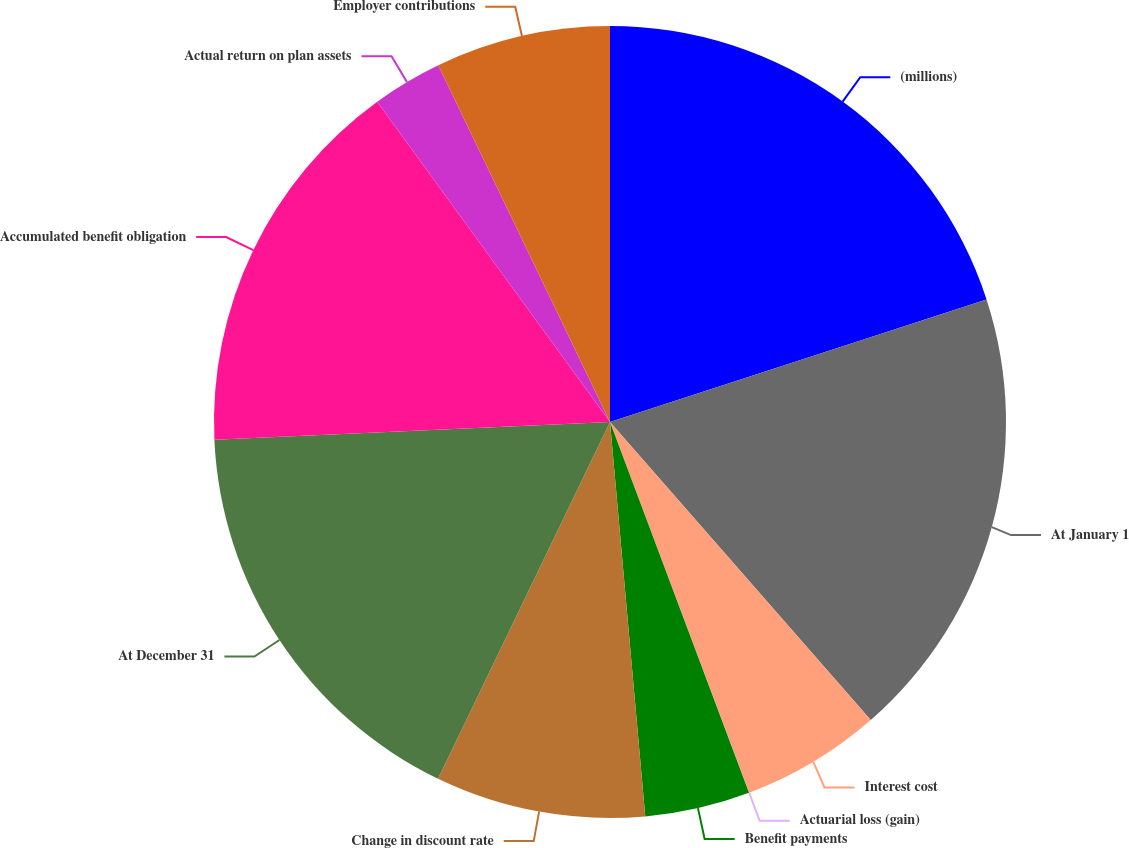<chart> <loc_0><loc_0><loc_500><loc_500><pie_chart><fcel>(millions)<fcel>At January 1<fcel>Interest cost<fcel>Actuarial loss (gain)<fcel>Benefit payments<fcel>Change in discount rate<fcel>At December 31<fcel>Accumulated benefit obligation<fcel>Actual return on plan assets<fcel>Employer contributions<nl><fcel>19.99%<fcel>18.57%<fcel>5.72%<fcel>0.01%<fcel>4.29%<fcel>8.57%<fcel>17.14%<fcel>15.71%<fcel>2.86%<fcel>7.14%<nl></chart> 